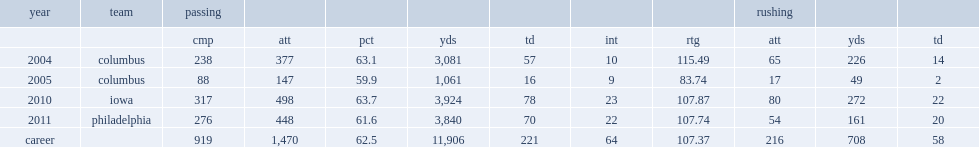How many passing yards did ryan vena get in 2010? 3924.0. 